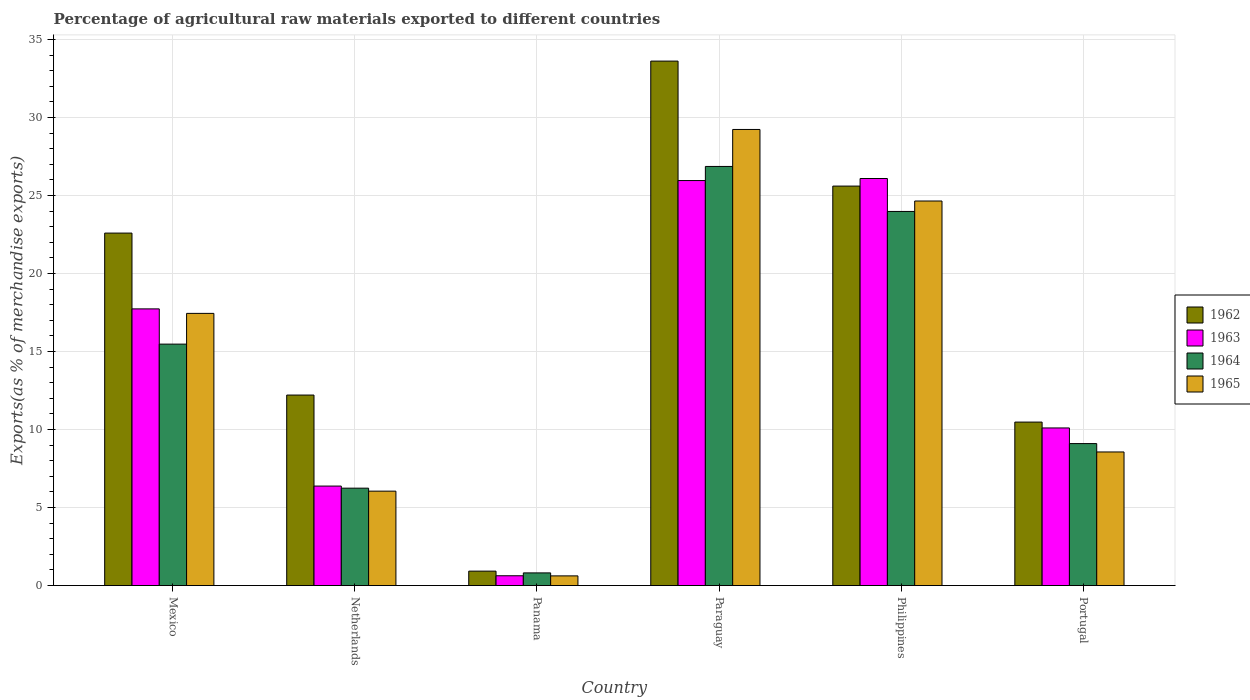Are the number of bars per tick equal to the number of legend labels?
Make the answer very short. Yes. Are the number of bars on each tick of the X-axis equal?
Provide a short and direct response. Yes. How many bars are there on the 1st tick from the right?
Your answer should be compact. 4. What is the label of the 5th group of bars from the left?
Offer a very short reply. Philippines. What is the percentage of exports to different countries in 1965 in Philippines?
Provide a short and direct response. 24.65. Across all countries, what is the maximum percentage of exports to different countries in 1962?
Your answer should be compact. 33.61. Across all countries, what is the minimum percentage of exports to different countries in 1965?
Provide a short and direct response. 0.62. In which country was the percentage of exports to different countries in 1962 maximum?
Ensure brevity in your answer.  Paraguay. In which country was the percentage of exports to different countries in 1964 minimum?
Make the answer very short. Panama. What is the total percentage of exports to different countries in 1962 in the graph?
Your response must be concise. 105.42. What is the difference between the percentage of exports to different countries in 1964 in Panama and that in Portugal?
Provide a short and direct response. -8.29. What is the difference between the percentage of exports to different countries in 1962 in Netherlands and the percentage of exports to different countries in 1963 in Paraguay?
Your answer should be very brief. -13.75. What is the average percentage of exports to different countries in 1965 per country?
Your answer should be very brief. 14.43. What is the difference between the percentage of exports to different countries of/in 1962 and percentage of exports to different countries of/in 1963 in Philippines?
Your answer should be very brief. -0.49. What is the ratio of the percentage of exports to different countries in 1964 in Mexico to that in Portugal?
Give a very brief answer. 1.7. Is the percentage of exports to different countries in 1965 in Mexico less than that in Philippines?
Provide a short and direct response. Yes. Is the difference between the percentage of exports to different countries in 1962 in Netherlands and Philippines greater than the difference between the percentage of exports to different countries in 1963 in Netherlands and Philippines?
Provide a succinct answer. Yes. What is the difference between the highest and the second highest percentage of exports to different countries in 1962?
Offer a very short reply. 8.01. What is the difference between the highest and the lowest percentage of exports to different countries in 1963?
Your answer should be compact. 25.46. In how many countries, is the percentage of exports to different countries in 1965 greater than the average percentage of exports to different countries in 1965 taken over all countries?
Your answer should be compact. 3. Is the sum of the percentage of exports to different countries in 1963 in Mexico and Panama greater than the maximum percentage of exports to different countries in 1965 across all countries?
Your response must be concise. No. Is it the case that in every country, the sum of the percentage of exports to different countries in 1965 and percentage of exports to different countries in 1962 is greater than the sum of percentage of exports to different countries in 1963 and percentage of exports to different countries in 1964?
Offer a very short reply. No. What does the 1st bar from the right in Portugal represents?
Give a very brief answer. 1965. Is it the case that in every country, the sum of the percentage of exports to different countries in 1962 and percentage of exports to different countries in 1964 is greater than the percentage of exports to different countries in 1965?
Offer a terse response. Yes. Are the values on the major ticks of Y-axis written in scientific E-notation?
Keep it short and to the point. No. Does the graph contain any zero values?
Provide a short and direct response. No. Does the graph contain grids?
Offer a terse response. Yes. How are the legend labels stacked?
Make the answer very short. Vertical. What is the title of the graph?
Provide a short and direct response. Percentage of agricultural raw materials exported to different countries. What is the label or title of the Y-axis?
Provide a short and direct response. Exports(as % of merchandise exports). What is the Exports(as % of merchandise exports) of 1962 in Mexico?
Give a very brief answer. 22.59. What is the Exports(as % of merchandise exports) of 1963 in Mexico?
Your response must be concise. 17.73. What is the Exports(as % of merchandise exports) in 1964 in Mexico?
Ensure brevity in your answer.  15.48. What is the Exports(as % of merchandise exports) of 1965 in Mexico?
Provide a succinct answer. 17.44. What is the Exports(as % of merchandise exports) in 1962 in Netherlands?
Give a very brief answer. 12.21. What is the Exports(as % of merchandise exports) in 1963 in Netherlands?
Give a very brief answer. 6.38. What is the Exports(as % of merchandise exports) of 1964 in Netherlands?
Ensure brevity in your answer.  6.24. What is the Exports(as % of merchandise exports) of 1965 in Netherlands?
Provide a short and direct response. 6.05. What is the Exports(as % of merchandise exports) in 1962 in Panama?
Offer a terse response. 0.92. What is the Exports(as % of merchandise exports) in 1963 in Panama?
Your response must be concise. 0.63. What is the Exports(as % of merchandise exports) of 1964 in Panama?
Ensure brevity in your answer.  0.81. What is the Exports(as % of merchandise exports) of 1965 in Panama?
Ensure brevity in your answer.  0.62. What is the Exports(as % of merchandise exports) in 1962 in Paraguay?
Provide a short and direct response. 33.61. What is the Exports(as % of merchandise exports) in 1963 in Paraguay?
Ensure brevity in your answer.  25.96. What is the Exports(as % of merchandise exports) in 1964 in Paraguay?
Provide a short and direct response. 26.86. What is the Exports(as % of merchandise exports) of 1965 in Paraguay?
Provide a succinct answer. 29.23. What is the Exports(as % of merchandise exports) in 1962 in Philippines?
Your response must be concise. 25.6. What is the Exports(as % of merchandise exports) of 1963 in Philippines?
Offer a terse response. 26.09. What is the Exports(as % of merchandise exports) in 1964 in Philippines?
Offer a terse response. 23.98. What is the Exports(as % of merchandise exports) in 1965 in Philippines?
Give a very brief answer. 24.65. What is the Exports(as % of merchandise exports) of 1962 in Portugal?
Provide a short and direct response. 10.48. What is the Exports(as % of merchandise exports) in 1963 in Portugal?
Your response must be concise. 10.1. What is the Exports(as % of merchandise exports) of 1964 in Portugal?
Make the answer very short. 9.1. What is the Exports(as % of merchandise exports) of 1965 in Portugal?
Your answer should be very brief. 8.56. Across all countries, what is the maximum Exports(as % of merchandise exports) of 1962?
Your answer should be compact. 33.61. Across all countries, what is the maximum Exports(as % of merchandise exports) in 1963?
Offer a terse response. 26.09. Across all countries, what is the maximum Exports(as % of merchandise exports) in 1964?
Make the answer very short. 26.86. Across all countries, what is the maximum Exports(as % of merchandise exports) of 1965?
Provide a short and direct response. 29.23. Across all countries, what is the minimum Exports(as % of merchandise exports) in 1962?
Provide a succinct answer. 0.92. Across all countries, what is the minimum Exports(as % of merchandise exports) of 1963?
Make the answer very short. 0.63. Across all countries, what is the minimum Exports(as % of merchandise exports) in 1964?
Provide a short and direct response. 0.81. Across all countries, what is the minimum Exports(as % of merchandise exports) of 1965?
Ensure brevity in your answer.  0.62. What is the total Exports(as % of merchandise exports) in 1962 in the graph?
Keep it short and to the point. 105.42. What is the total Exports(as % of merchandise exports) in 1963 in the graph?
Offer a very short reply. 86.89. What is the total Exports(as % of merchandise exports) in 1964 in the graph?
Give a very brief answer. 82.47. What is the total Exports(as % of merchandise exports) of 1965 in the graph?
Your answer should be very brief. 86.56. What is the difference between the Exports(as % of merchandise exports) in 1962 in Mexico and that in Netherlands?
Offer a terse response. 10.38. What is the difference between the Exports(as % of merchandise exports) in 1963 in Mexico and that in Netherlands?
Offer a very short reply. 11.36. What is the difference between the Exports(as % of merchandise exports) of 1964 in Mexico and that in Netherlands?
Offer a terse response. 9.23. What is the difference between the Exports(as % of merchandise exports) of 1965 in Mexico and that in Netherlands?
Give a very brief answer. 11.39. What is the difference between the Exports(as % of merchandise exports) of 1962 in Mexico and that in Panama?
Keep it short and to the point. 21.67. What is the difference between the Exports(as % of merchandise exports) of 1963 in Mexico and that in Panama?
Make the answer very short. 17.11. What is the difference between the Exports(as % of merchandise exports) in 1964 in Mexico and that in Panama?
Make the answer very short. 14.66. What is the difference between the Exports(as % of merchandise exports) of 1965 in Mexico and that in Panama?
Make the answer very short. 16.82. What is the difference between the Exports(as % of merchandise exports) of 1962 in Mexico and that in Paraguay?
Your answer should be very brief. -11.02. What is the difference between the Exports(as % of merchandise exports) in 1963 in Mexico and that in Paraguay?
Provide a succinct answer. -8.23. What is the difference between the Exports(as % of merchandise exports) of 1964 in Mexico and that in Paraguay?
Provide a short and direct response. -11.39. What is the difference between the Exports(as % of merchandise exports) in 1965 in Mexico and that in Paraguay?
Your answer should be compact. -11.79. What is the difference between the Exports(as % of merchandise exports) of 1962 in Mexico and that in Philippines?
Offer a terse response. -3.01. What is the difference between the Exports(as % of merchandise exports) of 1963 in Mexico and that in Philippines?
Keep it short and to the point. -8.36. What is the difference between the Exports(as % of merchandise exports) of 1964 in Mexico and that in Philippines?
Ensure brevity in your answer.  -8.5. What is the difference between the Exports(as % of merchandise exports) of 1965 in Mexico and that in Philippines?
Offer a terse response. -7.2. What is the difference between the Exports(as % of merchandise exports) of 1962 in Mexico and that in Portugal?
Give a very brief answer. 12.11. What is the difference between the Exports(as % of merchandise exports) of 1963 in Mexico and that in Portugal?
Your answer should be very brief. 7.63. What is the difference between the Exports(as % of merchandise exports) of 1964 in Mexico and that in Portugal?
Make the answer very short. 6.38. What is the difference between the Exports(as % of merchandise exports) of 1965 in Mexico and that in Portugal?
Provide a short and direct response. 8.88. What is the difference between the Exports(as % of merchandise exports) of 1962 in Netherlands and that in Panama?
Your answer should be compact. 11.29. What is the difference between the Exports(as % of merchandise exports) in 1963 in Netherlands and that in Panama?
Provide a succinct answer. 5.75. What is the difference between the Exports(as % of merchandise exports) of 1964 in Netherlands and that in Panama?
Your response must be concise. 5.43. What is the difference between the Exports(as % of merchandise exports) in 1965 in Netherlands and that in Panama?
Your response must be concise. 5.43. What is the difference between the Exports(as % of merchandise exports) of 1962 in Netherlands and that in Paraguay?
Your answer should be very brief. -21.4. What is the difference between the Exports(as % of merchandise exports) of 1963 in Netherlands and that in Paraguay?
Your answer should be very brief. -19.58. What is the difference between the Exports(as % of merchandise exports) in 1964 in Netherlands and that in Paraguay?
Keep it short and to the point. -20.62. What is the difference between the Exports(as % of merchandise exports) in 1965 in Netherlands and that in Paraguay?
Offer a very short reply. -23.18. What is the difference between the Exports(as % of merchandise exports) of 1962 in Netherlands and that in Philippines?
Provide a short and direct response. -13.39. What is the difference between the Exports(as % of merchandise exports) in 1963 in Netherlands and that in Philippines?
Keep it short and to the point. -19.71. What is the difference between the Exports(as % of merchandise exports) of 1964 in Netherlands and that in Philippines?
Your answer should be compact. -17.74. What is the difference between the Exports(as % of merchandise exports) in 1965 in Netherlands and that in Philippines?
Offer a terse response. -18.6. What is the difference between the Exports(as % of merchandise exports) of 1962 in Netherlands and that in Portugal?
Give a very brief answer. 1.73. What is the difference between the Exports(as % of merchandise exports) of 1963 in Netherlands and that in Portugal?
Give a very brief answer. -3.73. What is the difference between the Exports(as % of merchandise exports) of 1964 in Netherlands and that in Portugal?
Ensure brevity in your answer.  -2.86. What is the difference between the Exports(as % of merchandise exports) in 1965 in Netherlands and that in Portugal?
Offer a very short reply. -2.51. What is the difference between the Exports(as % of merchandise exports) of 1962 in Panama and that in Paraguay?
Your answer should be very brief. -32.69. What is the difference between the Exports(as % of merchandise exports) of 1963 in Panama and that in Paraguay?
Your response must be concise. -25.33. What is the difference between the Exports(as % of merchandise exports) in 1964 in Panama and that in Paraguay?
Provide a succinct answer. -26.05. What is the difference between the Exports(as % of merchandise exports) in 1965 in Panama and that in Paraguay?
Offer a terse response. -28.61. What is the difference between the Exports(as % of merchandise exports) of 1962 in Panama and that in Philippines?
Ensure brevity in your answer.  -24.68. What is the difference between the Exports(as % of merchandise exports) of 1963 in Panama and that in Philippines?
Provide a succinct answer. -25.46. What is the difference between the Exports(as % of merchandise exports) of 1964 in Panama and that in Philippines?
Provide a short and direct response. -23.17. What is the difference between the Exports(as % of merchandise exports) in 1965 in Panama and that in Philippines?
Your response must be concise. -24.03. What is the difference between the Exports(as % of merchandise exports) of 1962 in Panama and that in Portugal?
Ensure brevity in your answer.  -9.55. What is the difference between the Exports(as % of merchandise exports) in 1963 in Panama and that in Portugal?
Provide a succinct answer. -9.47. What is the difference between the Exports(as % of merchandise exports) of 1964 in Panama and that in Portugal?
Make the answer very short. -8.29. What is the difference between the Exports(as % of merchandise exports) of 1965 in Panama and that in Portugal?
Give a very brief answer. -7.94. What is the difference between the Exports(as % of merchandise exports) in 1962 in Paraguay and that in Philippines?
Provide a succinct answer. 8.01. What is the difference between the Exports(as % of merchandise exports) of 1963 in Paraguay and that in Philippines?
Your response must be concise. -0.13. What is the difference between the Exports(as % of merchandise exports) of 1964 in Paraguay and that in Philippines?
Give a very brief answer. 2.88. What is the difference between the Exports(as % of merchandise exports) of 1965 in Paraguay and that in Philippines?
Your answer should be compact. 4.59. What is the difference between the Exports(as % of merchandise exports) in 1962 in Paraguay and that in Portugal?
Your response must be concise. 23.14. What is the difference between the Exports(as % of merchandise exports) in 1963 in Paraguay and that in Portugal?
Your answer should be compact. 15.86. What is the difference between the Exports(as % of merchandise exports) of 1964 in Paraguay and that in Portugal?
Make the answer very short. 17.76. What is the difference between the Exports(as % of merchandise exports) in 1965 in Paraguay and that in Portugal?
Provide a short and direct response. 20.67. What is the difference between the Exports(as % of merchandise exports) of 1962 in Philippines and that in Portugal?
Your answer should be very brief. 15.13. What is the difference between the Exports(as % of merchandise exports) in 1963 in Philippines and that in Portugal?
Provide a succinct answer. 15.99. What is the difference between the Exports(as % of merchandise exports) of 1964 in Philippines and that in Portugal?
Give a very brief answer. 14.88. What is the difference between the Exports(as % of merchandise exports) in 1965 in Philippines and that in Portugal?
Offer a terse response. 16.08. What is the difference between the Exports(as % of merchandise exports) of 1962 in Mexico and the Exports(as % of merchandise exports) of 1963 in Netherlands?
Your answer should be very brief. 16.21. What is the difference between the Exports(as % of merchandise exports) of 1962 in Mexico and the Exports(as % of merchandise exports) of 1964 in Netherlands?
Provide a short and direct response. 16.35. What is the difference between the Exports(as % of merchandise exports) of 1962 in Mexico and the Exports(as % of merchandise exports) of 1965 in Netherlands?
Ensure brevity in your answer.  16.54. What is the difference between the Exports(as % of merchandise exports) in 1963 in Mexico and the Exports(as % of merchandise exports) in 1964 in Netherlands?
Keep it short and to the point. 11.49. What is the difference between the Exports(as % of merchandise exports) of 1963 in Mexico and the Exports(as % of merchandise exports) of 1965 in Netherlands?
Your answer should be compact. 11.68. What is the difference between the Exports(as % of merchandise exports) in 1964 in Mexico and the Exports(as % of merchandise exports) in 1965 in Netherlands?
Make the answer very short. 9.42. What is the difference between the Exports(as % of merchandise exports) in 1962 in Mexico and the Exports(as % of merchandise exports) in 1963 in Panama?
Offer a very short reply. 21.96. What is the difference between the Exports(as % of merchandise exports) in 1962 in Mexico and the Exports(as % of merchandise exports) in 1964 in Panama?
Ensure brevity in your answer.  21.78. What is the difference between the Exports(as % of merchandise exports) of 1962 in Mexico and the Exports(as % of merchandise exports) of 1965 in Panama?
Keep it short and to the point. 21.97. What is the difference between the Exports(as % of merchandise exports) of 1963 in Mexico and the Exports(as % of merchandise exports) of 1964 in Panama?
Provide a short and direct response. 16.92. What is the difference between the Exports(as % of merchandise exports) of 1963 in Mexico and the Exports(as % of merchandise exports) of 1965 in Panama?
Ensure brevity in your answer.  17.11. What is the difference between the Exports(as % of merchandise exports) of 1964 in Mexico and the Exports(as % of merchandise exports) of 1965 in Panama?
Make the answer very short. 14.85. What is the difference between the Exports(as % of merchandise exports) of 1962 in Mexico and the Exports(as % of merchandise exports) of 1963 in Paraguay?
Provide a succinct answer. -3.37. What is the difference between the Exports(as % of merchandise exports) of 1962 in Mexico and the Exports(as % of merchandise exports) of 1964 in Paraguay?
Your response must be concise. -4.27. What is the difference between the Exports(as % of merchandise exports) in 1962 in Mexico and the Exports(as % of merchandise exports) in 1965 in Paraguay?
Your answer should be very brief. -6.64. What is the difference between the Exports(as % of merchandise exports) of 1963 in Mexico and the Exports(as % of merchandise exports) of 1964 in Paraguay?
Your answer should be very brief. -9.13. What is the difference between the Exports(as % of merchandise exports) of 1963 in Mexico and the Exports(as % of merchandise exports) of 1965 in Paraguay?
Your response must be concise. -11.5. What is the difference between the Exports(as % of merchandise exports) in 1964 in Mexico and the Exports(as % of merchandise exports) in 1965 in Paraguay?
Your response must be concise. -13.76. What is the difference between the Exports(as % of merchandise exports) in 1962 in Mexico and the Exports(as % of merchandise exports) in 1963 in Philippines?
Give a very brief answer. -3.5. What is the difference between the Exports(as % of merchandise exports) in 1962 in Mexico and the Exports(as % of merchandise exports) in 1964 in Philippines?
Make the answer very short. -1.39. What is the difference between the Exports(as % of merchandise exports) in 1962 in Mexico and the Exports(as % of merchandise exports) in 1965 in Philippines?
Provide a succinct answer. -2.06. What is the difference between the Exports(as % of merchandise exports) of 1963 in Mexico and the Exports(as % of merchandise exports) of 1964 in Philippines?
Your response must be concise. -6.25. What is the difference between the Exports(as % of merchandise exports) in 1963 in Mexico and the Exports(as % of merchandise exports) in 1965 in Philippines?
Provide a short and direct response. -6.91. What is the difference between the Exports(as % of merchandise exports) of 1964 in Mexico and the Exports(as % of merchandise exports) of 1965 in Philippines?
Ensure brevity in your answer.  -9.17. What is the difference between the Exports(as % of merchandise exports) in 1962 in Mexico and the Exports(as % of merchandise exports) in 1963 in Portugal?
Make the answer very short. 12.49. What is the difference between the Exports(as % of merchandise exports) of 1962 in Mexico and the Exports(as % of merchandise exports) of 1964 in Portugal?
Keep it short and to the point. 13.49. What is the difference between the Exports(as % of merchandise exports) of 1962 in Mexico and the Exports(as % of merchandise exports) of 1965 in Portugal?
Provide a succinct answer. 14.03. What is the difference between the Exports(as % of merchandise exports) in 1963 in Mexico and the Exports(as % of merchandise exports) in 1964 in Portugal?
Keep it short and to the point. 8.63. What is the difference between the Exports(as % of merchandise exports) in 1963 in Mexico and the Exports(as % of merchandise exports) in 1965 in Portugal?
Keep it short and to the point. 9.17. What is the difference between the Exports(as % of merchandise exports) of 1964 in Mexico and the Exports(as % of merchandise exports) of 1965 in Portugal?
Your answer should be compact. 6.91. What is the difference between the Exports(as % of merchandise exports) in 1962 in Netherlands and the Exports(as % of merchandise exports) in 1963 in Panama?
Your answer should be very brief. 11.58. What is the difference between the Exports(as % of merchandise exports) in 1962 in Netherlands and the Exports(as % of merchandise exports) in 1964 in Panama?
Offer a terse response. 11.4. What is the difference between the Exports(as % of merchandise exports) in 1962 in Netherlands and the Exports(as % of merchandise exports) in 1965 in Panama?
Provide a short and direct response. 11.59. What is the difference between the Exports(as % of merchandise exports) of 1963 in Netherlands and the Exports(as % of merchandise exports) of 1964 in Panama?
Provide a succinct answer. 5.56. What is the difference between the Exports(as % of merchandise exports) in 1963 in Netherlands and the Exports(as % of merchandise exports) in 1965 in Panama?
Your answer should be compact. 5.76. What is the difference between the Exports(as % of merchandise exports) of 1964 in Netherlands and the Exports(as % of merchandise exports) of 1965 in Panama?
Ensure brevity in your answer.  5.62. What is the difference between the Exports(as % of merchandise exports) of 1962 in Netherlands and the Exports(as % of merchandise exports) of 1963 in Paraguay?
Offer a very short reply. -13.75. What is the difference between the Exports(as % of merchandise exports) in 1962 in Netherlands and the Exports(as % of merchandise exports) in 1964 in Paraguay?
Ensure brevity in your answer.  -14.65. What is the difference between the Exports(as % of merchandise exports) in 1962 in Netherlands and the Exports(as % of merchandise exports) in 1965 in Paraguay?
Your answer should be very brief. -17.02. What is the difference between the Exports(as % of merchandise exports) of 1963 in Netherlands and the Exports(as % of merchandise exports) of 1964 in Paraguay?
Provide a short and direct response. -20.49. What is the difference between the Exports(as % of merchandise exports) of 1963 in Netherlands and the Exports(as % of merchandise exports) of 1965 in Paraguay?
Offer a terse response. -22.86. What is the difference between the Exports(as % of merchandise exports) of 1964 in Netherlands and the Exports(as % of merchandise exports) of 1965 in Paraguay?
Offer a very short reply. -22.99. What is the difference between the Exports(as % of merchandise exports) in 1962 in Netherlands and the Exports(as % of merchandise exports) in 1963 in Philippines?
Ensure brevity in your answer.  -13.88. What is the difference between the Exports(as % of merchandise exports) in 1962 in Netherlands and the Exports(as % of merchandise exports) in 1964 in Philippines?
Make the answer very short. -11.77. What is the difference between the Exports(as % of merchandise exports) in 1962 in Netherlands and the Exports(as % of merchandise exports) in 1965 in Philippines?
Make the answer very short. -12.44. What is the difference between the Exports(as % of merchandise exports) in 1963 in Netherlands and the Exports(as % of merchandise exports) in 1964 in Philippines?
Your response must be concise. -17.6. What is the difference between the Exports(as % of merchandise exports) of 1963 in Netherlands and the Exports(as % of merchandise exports) of 1965 in Philippines?
Offer a very short reply. -18.27. What is the difference between the Exports(as % of merchandise exports) of 1964 in Netherlands and the Exports(as % of merchandise exports) of 1965 in Philippines?
Your response must be concise. -18.4. What is the difference between the Exports(as % of merchandise exports) of 1962 in Netherlands and the Exports(as % of merchandise exports) of 1963 in Portugal?
Offer a very short reply. 2.11. What is the difference between the Exports(as % of merchandise exports) of 1962 in Netherlands and the Exports(as % of merchandise exports) of 1964 in Portugal?
Make the answer very short. 3.11. What is the difference between the Exports(as % of merchandise exports) in 1962 in Netherlands and the Exports(as % of merchandise exports) in 1965 in Portugal?
Ensure brevity in your answer.  3.65. What is the difference between the Exports(as % of merchandise exports) in 1963 in Netherlands and the Exports(as % of merchandise exports) in 1964 in Portugal?
Offer a terse response. -2.72. What is the difference between the Exports(as % of merchandise exports) of 1963 in Netherlands and the Exports(as % of merchandise exports) of 1965 in Portugal?
Provide a succinct answer. -2.19. What is the difference between the Exports(as % of merchandise exports) in 1964 in Netherlands and the Exports(as % of merchandise exports) in 1965 in Portugal?
Keep it short and to the point. -2.32. What is the difference between the Exports(as % of merchandise exports) in 1962 in Panama and the Exports(as % of merchandise exports) in 1963 in Paraguay?
Give a very brief answer. -25.03. What is the difference between the Exports(as % of merchandise exports) in 1962 in Panama and the Exports(as % of merchandise exports) in 1964 in Paraguay?
Your response must be concise. -25.94. What is the difference between the Exports(as % of merchandise exports) in 1962 in Panama and the Exports(as % of merchandise exports) in 1965 in Paraguay?
Offer a terse response. -28.31. What is the difference between the Exports(as % of merchandise exports) of 1963 in Panama and the Exports(as % of merchandise exports) of 1964 in Paraguay?
Ensure brevity in your answer.  -26.23. What is the difference between the Exports(as % of merchandise exports) of 1963 in Panama and the Exports(as % of merchandise exports) of 1965 in Paraguay?
Give a very brief answer. -28.6. What is the difference between the Exports(as % of merchandise exports) of 1964 in Panama and the Exports(as % of merchandise exports) of 1965 in Paraguay?
Your answer should be very brief. -28.42. What is the difference between the Exports(as % of merchandise exports) in 1962 in Panama and the Exports(as % of merchandise exports) in 1963 in Philippines?
Give a very brief answer. -25.16. What is the difference between the Exports(as % of merchandise exports) in 1962 in Panama and the Exports(as % of merchandise exports) in 1964 in Philippines?
Keep it short and to the point. -23.05. What is the difference between the Exports(as % of merchandise exports) of 1962 in Panama and the Exports(as % of merchandise exports) of 1965 in Philippines?
Provide a succinct answer. -23.72. What is the difference between the Exports(as % of merchandise exports) in 1963 in Panama and the Exports(as % of merchandise exports) in 1964 in Philippines?
Your answer should be compact. -23.35. What is the difference between the Exports(as % of merchandise exports) in 1963 in Panama and the Exports(as % of merchandise exports) in 1965 in Philippines?
Offer a very short reply. -24.02. What is the difference between the Exports(as % of merchandise exports) of 1964 in Panama and the Exports(as % of merchandise exports) of 1965 in Philippines?
Your answer should be very brief. -23.84. What is the difference between the Exports(as % of merchandise exports) in 1962 in Panama and the Exports(as % of merchandise exports) in 1963 in Portugal?
Offer a very short reply. -9.18. What is the difference between the Exports(as % of merchandise exports) of 1962 in Panama and the Exports(as % of merchandise exports) of 1964 in Portugal?
Give a very brief answer. -8.17. What is the difference between the Exports(as % of merchandise exports) of 1962 in Panama and the Exports(as % of merchandise exports) of 1965 in Portugal?
Your answer should be very brief. -7.64. What is the difference between the Exports(as % of merchandise exports) in 1963 in Panama and the Exports(as % of merchandise exports) in 1964 in Portugal?
Your answer should be compact. -8.47. What is the difference between the Exports(as % of merchandise exports) of 1963 in Panama and the Exports(as % of merchandise exports) of 1965 in Portugal?
Your response must be concise. -7.93. What is the difference between the Exports(as % of merchandise exports) of 1964 in Panama and the Exports(as % of merchandise exports) of 1965 in Portugal?
Make the answer very short. -7.75. What is the difference between the Exports(as % of merchandise exports) in 1962 in Paraguay and the Exports(as % of merchandise exports) in 1963 in Philippines?
Provide a short and direct response. 7.53. What is the difference between the Exports(as % of merchandise exports) of 1962 in Paraguay and the Exports(as % of merchandise exports) of 1964 in Philippines?
Your answer should be compact. 9.64. What is the difference between the Exports(as % of merchandise exports) in 1962 in Paraguay and the Exports(as % of merchandise exports) in 1965 in Philippines?
Make the answer very short. 8.97. What is the difference between the Exports(as % of merchandise exports) in 1963 in Paraguay and the Exports(as % of merchandise exports) in 1964 in Philippines?
Provide a short and direct response. 1.98. What is the difference between the Exports(as % of merchandise exports) of 1963 in Paraguay and the Exports(as % of merchandise exports) of 1965 in Philippines?
Give a very brief answer. 1.31. What is the difference between the Exports(as % of merchandise exports) in 1964 in Paraguay and the Exports(as % of merchandise exports) in 1965 in Philippines?
Keep it short and to the point. 2.22. What is the difference between the Exports(as % of merchandise exports) in 1962 in Paraguay and the Exports(as % of merchandise exports) in 1963 in Portugal?
Your response must be concise. 23.51. What is the difference between the Exports(as % of merchandise exports) in 1962 in Paraguay and the Exports(as % of merchandise exports) in 1964 in Portugal?
Your answer should be very brief. 24.52. What is the difference between the Exports(as % of merchandise exports) in 1962 in Paraguay and the Exports(as % of merchandise exports) in 1965 in Portugal?
Offer a very short reply. 25.05. What is the difference between the Exports(as % of merchandise exports) of 1963 in Paraguay and the Exports(as % of merchandise exports) of 1964 in Portugal?
Offer a terse response. 16.86. What is the difference between the Exports(as % of merchandise exports) in 1963 in Paraguay and the Exports(as % of merchandise exports) in 1965 in Portugal?
Ensure brevity in your answer.  17.4. What is the difference between the Exports(as % of merchandise exports) of 1962 in Philippines and the Exports(as % of merchandise exports) of 1963 in Portugal?
Offer a terse response. 15.5. What is the difference between the Exports(as % of merchandise exports) in 1962 in Philippines and the Exports(as % of merchandise exports) in 1964 in Portugal?
Make the answer very short. 16.5. What is the difference between the Exports(as % of merchandise exports) in 1962 in Philippines and the Exports(as % of merchandise exports) in 1965 in Portugal?
Your response must be concise. 17.04. What is the difference between the Exports(as % of merchandise exports) of 1963 in Philippines and the Exports(as % of merchandise exports) of 1964 in Portugal?
Your answer should be very brief. 16.99. What is the difference between the Exports(as % of merchandise exports) in 1963 in Philippines and the Exports(as % of merchandise exports) in 1965 in Portugal?
Give a very brief answer. 17.53. What is the difference between the Exports(as % of merchandise exports) in 1964 in Philippines and the Exports(as % of merchandise exports) in 1965 in Portugal?
Offer a terse response. 15.42. What is the average Exports(as % of merchandise exports) of 1962 per country?
Ensure brevity in your answer.  17.57. What is the average Exports(as % of merchandise exports) of 1963 per country?
Give a very brief answer. 14.48. What is the average Exports(as % of merchandise exports) in 1964 per country?
Give a very brief answer. 13.75. What is the average Exports(as % of merchandise exports) of 1965 per country?
Your answer should be very brief. 14.43. What is the difference between the Exports(as % of merchandise exports) in 1962 and Exports(as % of merchandise exports) in 1963 in Mexico?
Provide a short and direct response. 4.86. What is the difference between the Exports(as % of merchandise exports) of 1962 and Exports(as % of merchandise exports) of 1964 in Mexico?
Your answer should be very brief. 7.12. What is the difference between the Exports(as % of merchandise exports) of 1962 and Exports(as % of merchandise exports) of 1965 in Mexico?
Your response must be concise. 5.15. What is the difference between the Exports(as % of merchandise exports) of 1963 and Exports(as % of merchandise exports) of 1964 in Mexico?
Give a very brief answer. 2.26. What is the difference between the Exports(as % of merchandise exports) of 1963 and Exports(as % of merchandise exports) of 1965 in Mexico?
Your answer should be compact. 0.29. What is the difference between the Exports(as % of merchandise exports) of 1964 and Exports(as % of merchandise exports) of 1965 in Mexico?
Give a very brief answer. -1.97. What is the difference between the Exports(as % of merchandise exports) of 1962 and Exports(as % of merchandise exports) of 1963 in Netherlands?
Provide a succinct answer. 5.83. What is the difference between the Exports(as % of merchandise exports) of 1962 and Exports(as % of merchandise exports) of 1964 in Netherlands?
Offer a very short reply. 5.97. What is the difference between the Exports(as % of merchandise exports) of 1962 and Exports(as % of merchandise exports) of 1965 in Netherlands?
Your answer should be very brief. 6.16. What is the difference between the Exports(as % of merchandise exports) in 1963 and Exports(as % of merchandise exports) in 1964 in Netherlands?
Your answer should be compact. 0.13. What is the difference between the Exports(as % of merchandise exports) of 1963 and Exports(as % of merchandise exports) of 1965 in Netherlands?
Ensure brevity in your answer.  0.32. What is the difference between the Exports(as % of merchandise exports) in 1964 and Exports(as % of merchandise exports) in 1965 in Netherlands?
Offer a terse response. 0.19. What is the difference between the Exports(as % of merchandise exports) in 1962 and Exports(as % of merchandise exports) in 1963 in Panama?
Offer a very short reply. 0.3. What is the difference between the Exports(as % of merchandise exports) in 1962 and Exports(as % of merchandise exports) in 1964 in Panama?
Offer a very short reply. 0.11. What is the difference between the Exports(as % of merchandise exports) in 1962 and Exports(as % of merchandise exports) in 1965 in Panama?
Ensure brevity in your answer.  0.3. What is the difference between the Exports(as % of merchandise exports) in 1963 and Exports(as % of merchandise exports) in 1964 in Panama?
Make the answer very short. -0.18. What is the difference between the Exports(as % of merchandise exports) of 1963 and Exports(as % of merchandise exports) of 1965 in Panama?
Ensure brevity in your answer.  0.01. What is the difference between the Exports(as % of merchandise exports) of 1964 and Exports(as % of merchandise exports) of 1965 in Panama?
Ensure brevity in your answer.  0.19. What is the difference between the Exports(as % of merchandise exports) of 1962 and Exports(as % of merchandise exports) of 1963 in Paraguay?
Keep it short and to the point. 7.66. What is the difference between the Exports(as % of merchandise exports) of 1962 and Exports(as % of merchandise exports) of 1964 in Paraguay?
Your answer should be very brief. 6.75. What is the difference between the Exports(as % of merchandise exports) of 1962 and Exports(as % of merchandise exports) of 1965 in Paraguay?
Your answer should be very brief. 4.38. What is the difference between the Exports(as % of merchandise exports) of 1963 and Exports(as % of merchandise exports) of 1964 in Paraguay?
Provide a succinct answer. -0.9. What is the difference between the Exports(as % of merchandise exports) of 1963 and Exports(as % of merchandise exports) of 1965 in Paraguay?
Keep it short and to the point. -3.27. What is the difference between the Exports(as % of merchandise exports) in 1964 and Exports(as % of merchandise exports) in 1965 in Paraguay?
Provide a succinct answer. -2.37. What is the difference between the Exports(as % of merchandise exports) of 1962 and Exports(as % of merchandise exports) of 1963 in Philippines?
Keep it short and to the point. -0.49. What is the difference between the Exports(as % of merchandise exports) of 1962 and Exports(as % of merchandise exports) of 1964 in Philippines?
Offer a terse response. 1.63. What is the difference between the Exports(as % of merchandise exports) in 1962 and Exports(as % of merchandise exports) in 1965 in Philippines?
Your response must be concise. 0.96. What is the difference between the Exports(as % of merchandise exports) of 1963 and Exports(as % of merchandise exports) of 1964 in Philippines?
Your answer should be compact. 2.11. What is the difference between the Exports(as % of merchandise exports) of 1963 and Exports(as % of merchandise exports) of 1965 in Philippines?
Give a very brief answer. 1.44. What is the difference between the Exports(as % of merchandise exports) in 1964 and Exports(as % of merchandise exports) in 1965 in Philippines?
Keep it short and to the point. -0.67. What is the difference between the Exports(as % of merchandise exports) in 1962 and Exports(as % of merchandise exports) in 1963 in Portugal?
Keep it short and to the point. 0.38. What is the difference between the Exports(as % of merchandise exports) of 1962 and Exports(as % of merchandise exports) of 1964 in Portugal?
Your response must be concise. 1.38. What is the difference between the Exports(as % of merchandise exports) in 1962 and Exports(as % of merchandise exports) in 1965 in Portugal?
Make the answer very short. 1.92. What is the difference between the Exports(as % of merchandise exports) of 1963 and Exports(as % of merchandise exports) of 1964 in Portugal?
Provide a succinct answer. 1. What is the difference between the Exports(as % of merchandise exports) of 1963 and Exports(as % of merchandise exports) of 1965 in Portugal?
Provide a short and direct response. 1.54. What is the difference between the Exports(as % of merchandise exports) in 1964 and Exports(as % of merchandise exports) in 1965 in Portugal?
Your response must be concise. 0.54. What is the ratio of the Exports(as % of merchandise exports) in 1962 in Mexico to that in Netherlands?
Provide a succinct answer. 1.85. What is the ratio of the Exports(as % of merchandise exports) of 1963 in Mexico to that in Netherlands?
Provide a succinct answer. 2.78. What is the ratio of the Exports(as % of merchandise exports) of 1964 in Mexico to that in Netherlands?
Your response must be concise. 2.48. What is the ratio of the Exports(as % of merchandise exports) of 1965 in Mexico to that in Netherlands?
Ensure brevity in your answer.  2.88. What is the ratio of the Exports(as % of merchandise exports) in 1962 in Mexico to that in Panama?
Your answer should be very brief. 24.43. What is the ratio of the Exports(as % of merchandise exports) of 1963 in Mexico to that in Panama?
Your answer should be very brief. 28.23. What is the ratio of the Exports(as % of merchandise exports) of 1964 in Mexico to that in Panama?
Offer a very short reply. 19.05. What is the ratio of the Exports(as % of merchandise exports) in 1965 in Mexico to that in Panama?
Your answer should be very brief. 28.11. What is the ratio of the Exports(as % of merchandise exports) in 1962 in Mexico to that in Paraguay?
Offer a terse response. 0.67. What is the ratio of the Exports(as % of merchandise exports) in 1963 in Mexico to that in Paraguay?
Provide a short and direct response. 0.68. What is the ratio of the Exports(as % of merchandise exports) in 1964 in Mexico to that in Paraguay?
Make the answer very short. 0.58. What is the ratio of the Exports(as % of merchandise exports) in 1965 in Mexico to that in Paraguay?
Your response must be concise. 0.6. What is the ratio of the Exports(as % of merchandise exports) of 1962 in Mexico to that in Philippines?
Offer a very short reply. 0.88. What is the ratio of the Exports(as % of merchandise exports) of 1963 in Mexico to that in Philippines?
Your response must be concise. 0.68. What is the ratio of the Exports(as % of merchandise exports) of 1964 in Mexico to that in Philippines?
Provide a succinct answer. 0.65. What is the ratio of the Exports(as % of merchandise exports) in 1965 in Mexico to that in Philippines?
Your answer should be very brief. 0.71. What is the ratio of the Exports(as % of merchandise exports) in 1962 in Mexico to that in Portugal?
Provide a short and direct response. 2.16. What is the ratio of the Exports(as % of merchandise exports) of 1963 in Mexico to that in Portugal?
Keep it short and to the point. 1.76. What is the ratio of the Exports(as % of merchandise exports) in 1964 in Mexico to that in Portugal?
Ensure brevity in your answer.  1.7. What is the ratio of the Exports(as % of merchandise exports) of 1965 in Mexico to that in Portugal?
Your answer should be very brief. 2.04. What is the ratio of the Exports(as % of merchandise exports) of 1962 in Netherlands to that in Panama?
Offer a terse response. 13.21. What is the ratio of the Exports(as % of merchandise exports) of 1963 in Netherlands to that in Panama?
Make the answer very short. 10.15. What is the ratio of the Exports(as % of merchandise exports) of 1964 in Netherlands to that in Panama?
Give a very brief answer. 7.69. What is the ratio of the Exports(as % of merchandise exports) in 1965 in Netherlands to that in Panama?
Provide a succinct answer. 9.75. What is the ratio of the Exports(as % of merchandise exports) of 1962 in Netherlands to that in Paraguay?
Make the answer very short. 0.36. What is the ratio of the Exports(as % of merchandise exports) of 1963 in Netherlands to that in Paraguay?
Offer a terse response. 0.25. What is the ratio of the Exports(as % of merchandise exports) of 1964 in Netherlands to that in Paraguay?
Your response must be concise. 0.23. What is the ratio of the Exports(as % of merchandise exports) in 1965 in Netherlands to that in Paraguay?
Your answer should be compact. 0.21. What is the ratio of the Exports(as % of merchandise exports) of 1962 in Netherlands to that in Philippines?
Offer a terse response. 0.48. What is the ratio of the Exports(as % of merchandise exports) in 1963 in Netherlands to that in Philippines?
Your answer should be compact. 0.24. What is the ratio of the Exports(as % of merchandise exports) of 1964 in Netherlands to that in Philippines?
Provide a short and direct response. 0.26. What is the ratio of the Exports(as % of merchandise exports) in 1965 in Netherlands to that in Philippines?
Provide a short and direct response. 0.25. What is the ratio of the Exports(as % of merchandise exports) of 1962 in Netherlands to that in Portugal?
Keep it short and to the point. 1.17. What is the ratio of the Exports(as % of merchandise exports) in 1963 in Netherlands to that in Portugal?
Your answer should be very brief. 0.63. What is the ratio of the Exports(as % of merchandise exports) in 1964 in Netherlands to that in Portugal?
Your answer should be very brief. 0.69. What is the ratio of the Exports(as % of merchandise exports) in 1965 in Netherlands to that in Portugal?
Your answer should be compact. 0.71. What is the ratio of the Exports(as % of merchandise exports) of 1962 in Panama to that in Paraguay?
Offer a terse response. 0.03. What is the ratio of the Exports(as % of merchandise exports) of 1963 in Panama to that in Paraguay?
Your response must be concise. 0.02. What is the ratio of the Exports(as % of merchandise exports) of 1964 in Panama to that in Paraguay?
Offer a very short reply. 0.03. What is the ratio of the Exports(as % of merchandise exports) of 1965 in Panama to that in Paraguay?
Your response must be concise. 0.02. What is the ratio of the Exports(as % of merchandise exports) in 1962 in Panama to that in Philippines?
Your answer should be very brief. 0.04. What is the ratio of the Exports(as % of merchandise exports) in 1963 in Panama to that in Philippines?
Ensure brevity in your answer.  0.02. What is the ratio of the Exports(as % of merchandise exports) in 1964 in Panama to that in Philippines?
Offer a terse response. 0.03. What is the ratio of the Exports(as % of merchandise exports) of 1965 in Panama to that in Philippines?
Make the answer very short. 0.03. What is the ratio of the Exports(as % of merchandise exports) in 1962 in Panama to that in Portugal?
Your answer should be very brief. 0.09. What is the ratio of the Exports(as % of merchandise exports) in 1963 in Panama to that in Portugal?
Keep it short and to the point. 0.06. What is the ratio of the Exports(as % of merchandise exports) of 1964 in Panama to that in Portugal?
Ensure brevity in your answer.  0.09. What is the ratio of the Exports(as % of merchandise exports) in 1965 in Panama to that in Portugal?
Offer a terse response. 0.07. What is the ratio of the Exports(as % of merchandise exports) of 1962 in Paraguay to that in Philippines?
Provide a succinct answer. 1.31. What is the ratio of the Exports(as % of merchandise exports) in 1963 in Paraguay to that in Philippines?
Make the answer very short. 0.99. What is the ratio of the Exports(as % of merchandise exports) of 1964 in Paraguay to that in Philippines?
Make the answer very short. 1.12. What is the ratio of the Exports(as % of merchandise exports) of 1965 in Paraguay to that in Philippines?
Offer a very short reply. 1.19. What is the ratio of the Exports(as % of merchandise exports) of 1962 in Paraguay to that in Portugal?
Keep it short and to the point. 3.21. What is the ratio of the Exports(as % of merchandise exports) in 1963 in Paraguay to that in Portugal?
Offer a terse response. 2.57. What is the ratio of the Exports(as % of merchandise exports) of 1964 in Paraguay to that in Portugal?
Your answer should be very brief. 2.95. What is the ratio of the Exports(as % of merchandise exports) of 1965 in Paraguay to that in Portugal?
Provide a succinct answer. 3.41. What is the ratio of the Exports(as % of merchandise exports) of 1962 in Philippines to that in Portugal?
Ensure brevity in your answer.  2.44. What is the ratio of the Exports(as % of merchandise exports) in 1963 in Philippines to that in Portugal?
Make the answer very short. 2.58. What is the ratio of the Exports(as % of merchandise exports) in 1964 in Philippines to that in Portugal?
Your answer should be compact. 2.64. What is the ratio of the Exports(as % of merchandise exports) of 1965 in Philippines to that in Portugal?
Make the answer very short. 2.88. What is the difference between the highest and the second highest Exports(as % of merchandise exports) of 1962?
Ensure brevity in your answer.  8.01. What is the difference between the highest and the second highest Exports(as % of merchandise exports) in 1963?
Ensure brevity in your answer.  0.13. What is the difference between the highest and the second highest Exports(as % of merchandise exports) of 1964?
Offer a terse response. 2.88. What is the difference between the highest and the second highest Exports(as % of merchandise exports) of 1965?
Your answer should be very brief. 4.59. What is the difference between the highest and the lowest Exports(as % of merchandise exports) of 1962?
Keep it short and to the point. 32.69. What is the difference between the highest and the lowest Exports(as % of merchandise exports) of 1963?
Keep it short and to the point. 25.46. What is the difference between the highest and the lowest Exports(as % of merchandise exports) in 1964?
Offer a very short reply. 26.05. What is the difference between the highest and the lowest Exports(as % of merchandise exports) in 1965?
Provide a succinct answer. 28.61. 